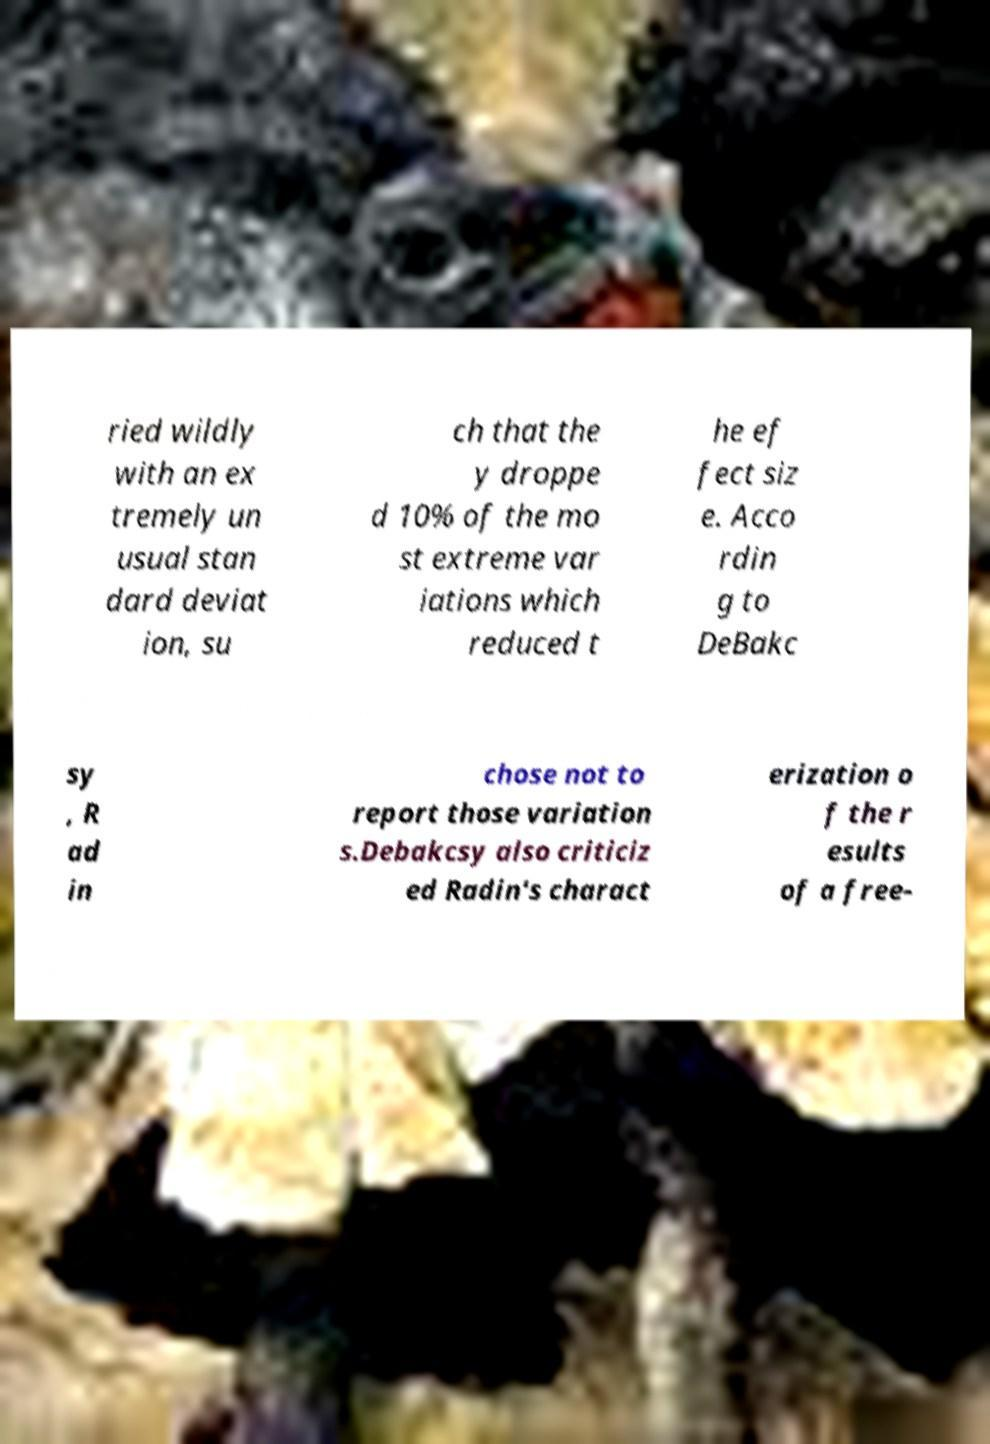Please identify and transcribe the text found in this image. ried wildly with an ex tremely un usual stan dard deviat ion, su ch that the y droppe d 10% of the mo st extreme var iations which reduced t he ef fect siz e. Acco rdin g to DeBakc sy , R ad in chose not to report those variation s.Debakcsy also criticiz ed Radin's charact erization o f the r esults of a free- 